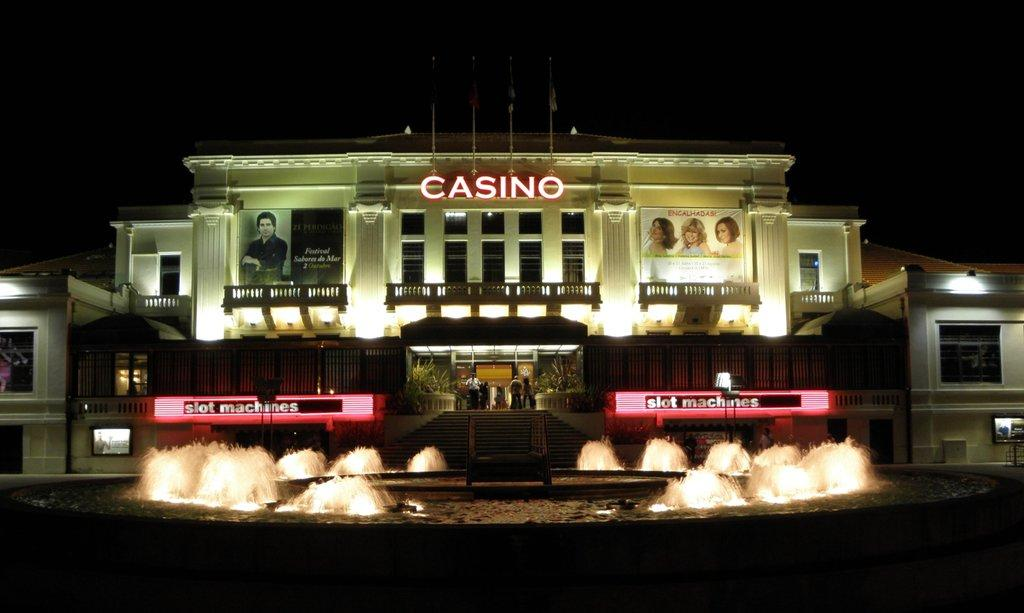What is located in the center of the image? There are buildings and lights in the center of the image. What can be seen in the foreground of the image? There is a fountain in the foreground of the image. Are there any signs or messages in the image? Yes, there are boards with text in the image. What type of mitten can be seen on the fountain in the image? There is no mitten present on the fountain in the image. What channel is being broadcasted on the boards with text in the image? The provided facts do not mention any channels or broadcasts; there are only boards with text. 